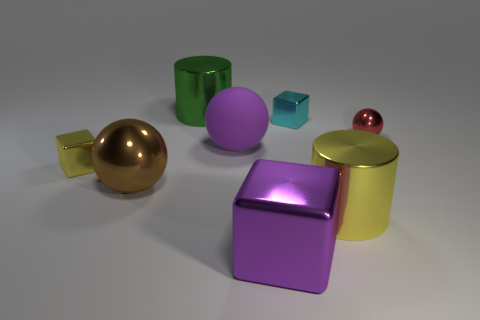What number of large spheres have the same color as the matte thing?
Your answer should be compact. 0. There is a purple cube that is the same material as the small yellow cube; what is its size?
Make the answer very short. Large. What number of things are either shiny cubes that are right of the rubber object or large green metal cylinders?
Give a very brief answer. 3. Is the color of the shiny cylinder that is in front of the tiny red ball the same as the large matte ball?
Your answer should be very brief. No. The yellow shiny thing that is the same shape as the large green object is what size?
Make the answer very short. Large. What is the color of the cube that is in front of the big cylinder that is in front of the small cube in front of the cyan cube?
Your answer should be compact. Purple. Do the red thing and the large purple block have the same material?
Offer a very short reply. Yes. Is there a big yellow cylinder behind the rubber ball left of the cylinder that is in front of the small cyan cube?
Provide a short and direct response. No. Is the large cube the same color as the large rubber object?
Ensure brevity in your answer.  Yes. Are there fewer things than big blue matte balls?
Give a very brief answer. No. 